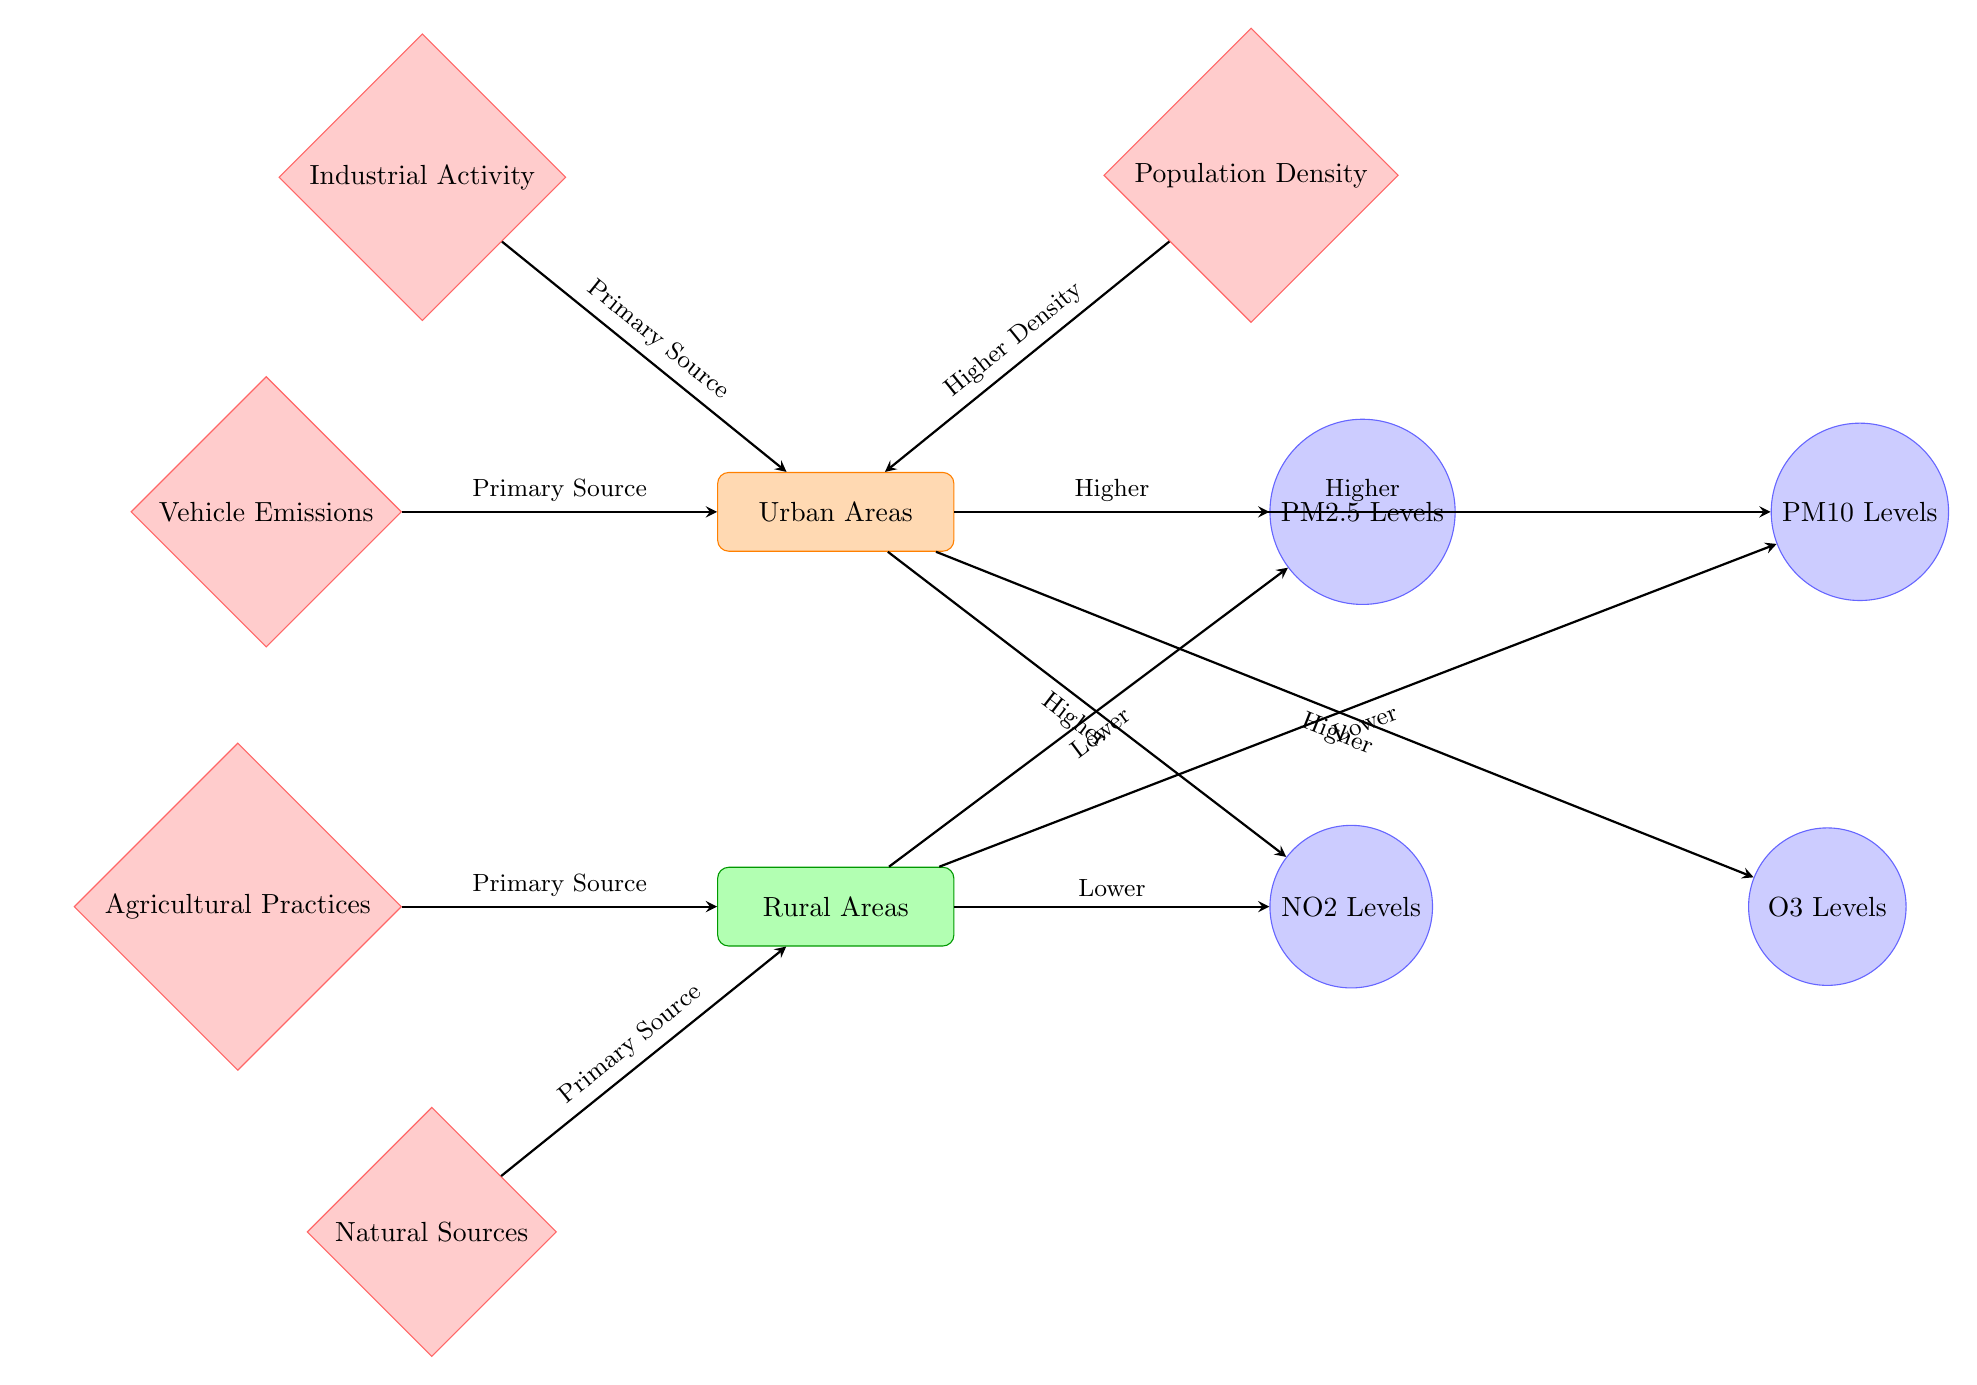What pollutant levels are higher in urban areas? The diagram indicates that PM2.5 levels, PM10 levels, NO2 levels, and O3 levels are all higher in urban areas.
Answer: PM2.5, PM10, NO2, O3 What is the primary source of air pollution in urban areas? According to the diagram, vehicle emissions and industrial activity are listed as primary sources of air pollution in urban areas.
Answer: Vehicle emissions, Industrial activity How many pollutants are shown in the diagram? The diagram displays a total of four pollutants: PM2.5, PM10, NO2, and O3.
Answer: Four Which area has lower PM2.5 levels? The diagram specifies that rural areas have lower PM2.5 levels compared to urban areas.
Answer: Rural Areas What role does population density play in urban air pollution? The diagram suggests that population density contributes to higher pollution levels in urban areas, implying that denser populations lead to increased emissions.
Answer: Higher Density Which pollutant level is not listed for rural areas? The diagram indicates that O3 levels are not present for rural areas.
Answer: O3 Levels What are the primary sources of pollution in rural areas? The diagram identifies agricultural practices and natural sources as the primary sources of pollution in rural areas.
Answer: Agricultural Practices, Natural Sources What type of diagram is used to represent air pollution levels? The diagram depicts information through a natural science diagram, which visualizes relationships between locations and sources of pollutants.
Answer: Natural Science Diagram Which area has a higher concentration of NO2 levels? The diagram clearly states that urban areas have higher concentrations of NO2 levels compared to rural areas.
Answer: Urban Areas 